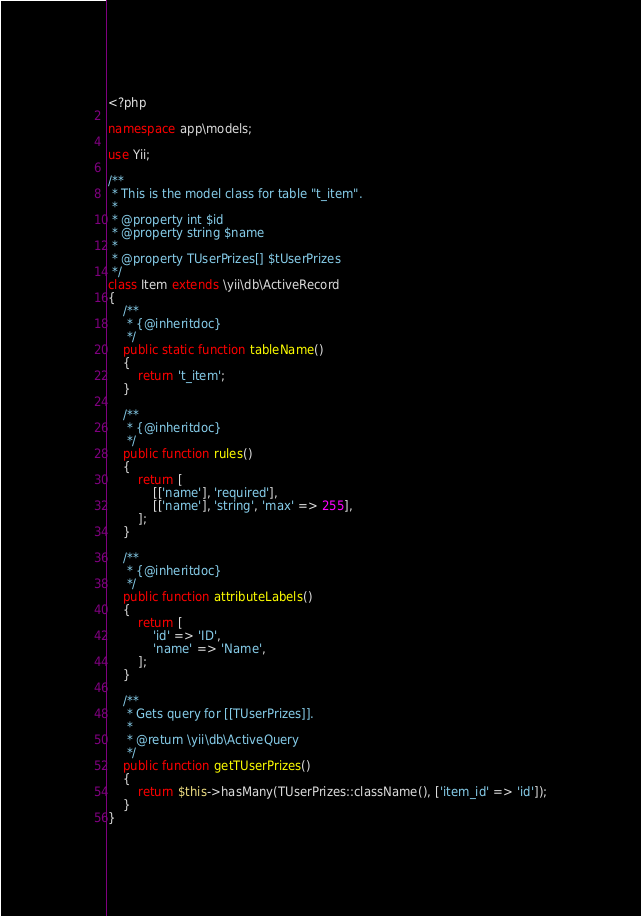Convert code to text. <code><loc_0><loc_0><loc_500><loc_500><_PHP_><?php

namespace app\models;

use Yii;

/**
 * This is the model class for table "t_item".
 *
 * @property int $id
 * @property string $name
 *
 * @property TUserPrizes[] $tUserPrizes
 */
class Item extends \yii\db\ActiveRecord
{
    /**
     * {@inheritdoc}
     */
    public static function tableName()
    {
        return 't_item';
    }

    /**
     * {@inheritdoc}
     */
    public function rules()
    {
        return [
            [['name'], 'required'],
            [['name'], 'string', 'max' => 255],
        ];
    }

    /**
     * {@inheritdoc}
     */
    public function attributeLabels()
    {
        return [
            'id' => 'ID',
            'name' => 'Name',
        ];
    }

    /**
     * Gets query for [[TUserPrizes]].
     *
     * @return \yii\db\ActiveQuery
     */
    public function getTUserPrizes()
    {
        return $this->hasMany(TUserPrizes::className(), ['item_id' => 'id']);
    }
}
</code> 